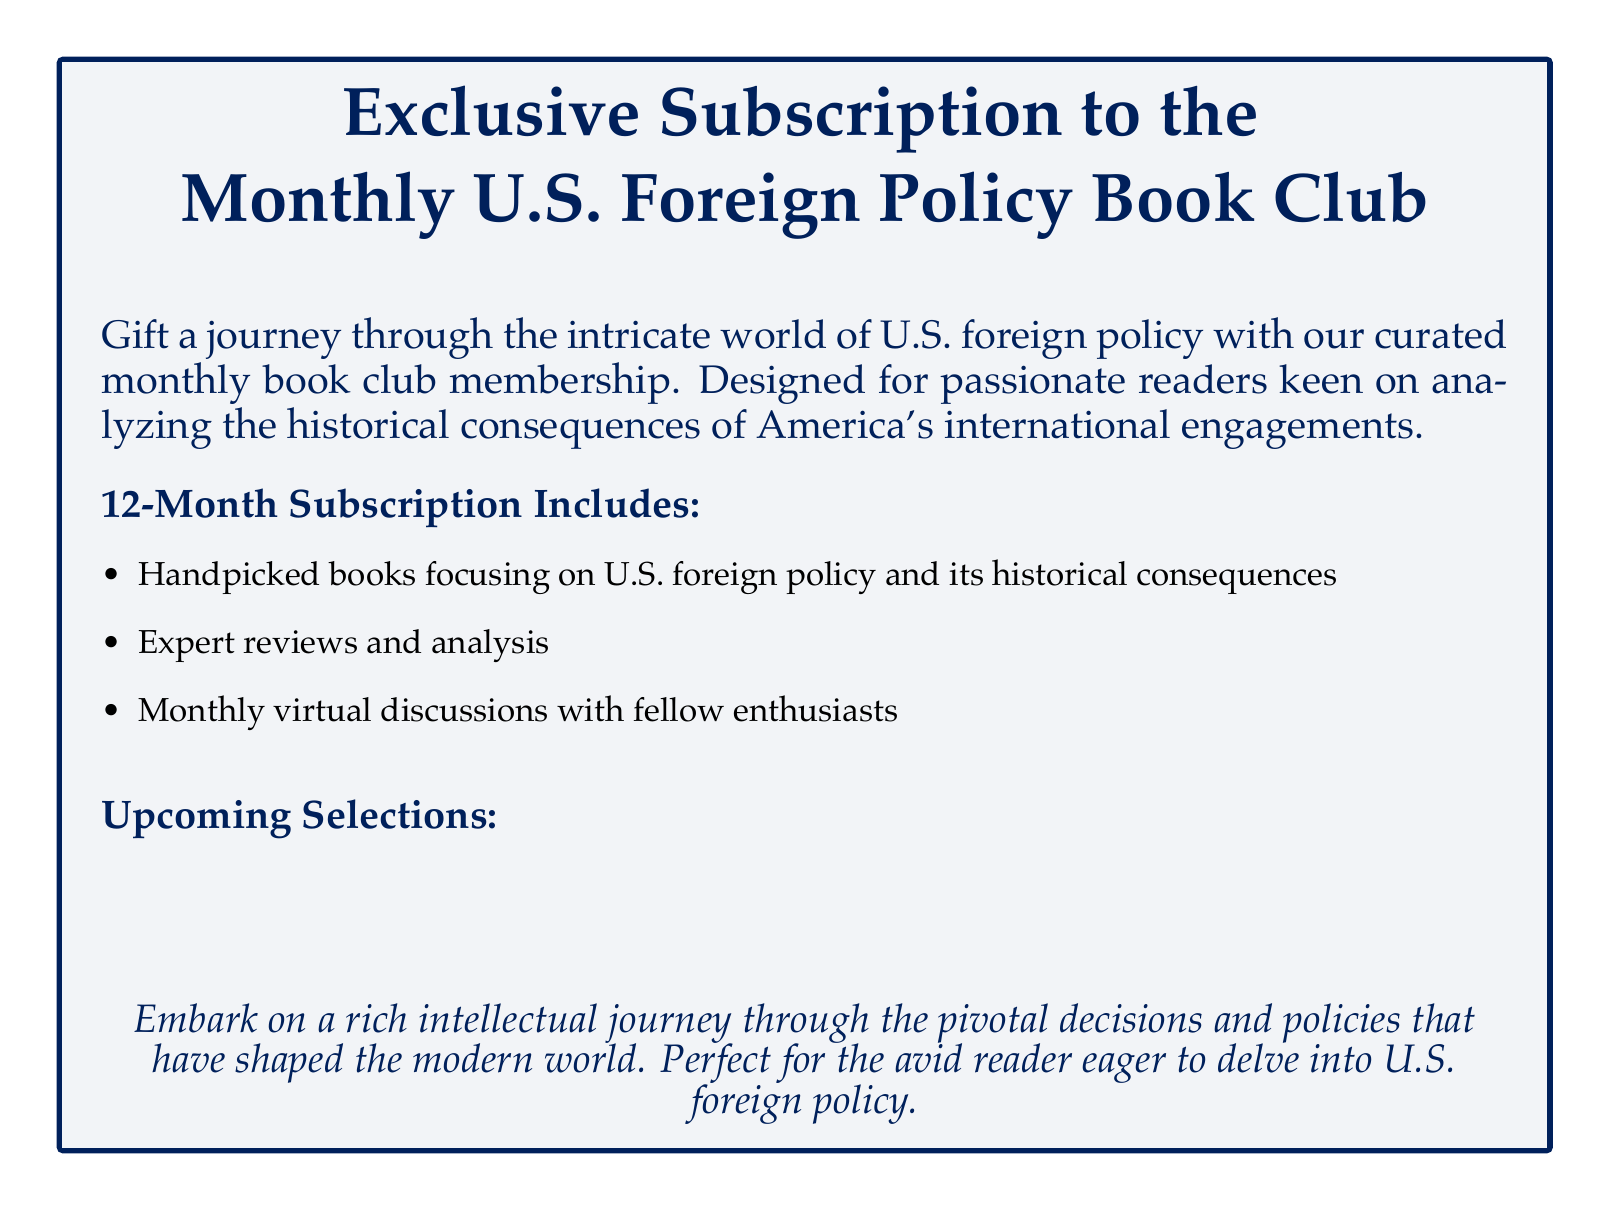What is the name of the book club? The book club is referred to as the "Monthly U.S. Foreign Policy Book Club."
Answer: Monthly U.S. Foreign Policy Book Club How many months does the subscription last? The document states that the subscription includes 12 months.
Answer: 12 months Who is the author of the book for January? The January selection is "The Tragedy of Great Power Politics," written by John J. Mearsheimer.
Answer: John J. Mearsheimer What type of discussions are included in the subscription? The document mentions "monthly virtual discussions with fellow enthusiasts."
Answer: Monthly virtual discussions What is the theme of the book for March? The March selection focuses on questioning the concept of American exceptionalism and its repercussions.
Answer: American exceptionalism and its repercussions Which book discusses China's strategy against the U.S.? The April selection is titled "The Long Game: China's Grand Strategy to Displace American Order."
Answer: The Long Game: China's Grand Strategy to Displace American Order What is the color of the box in the document? The color of the box is described as navy with a light background.
Answer: Navy Who is the author of the February book? The February book is authored by Hal Brands.
Answer: Hal Brands 